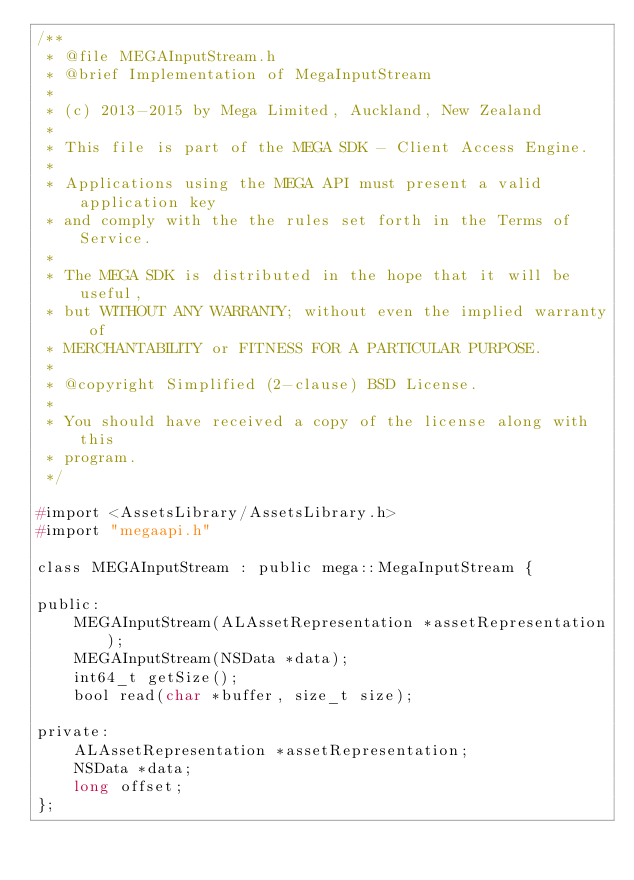Convert code to text. <code><loc_0><loc_0><loc_500><loc_500><_C_>/**
 * @file MEGAInputStream.h
 * @brief Implementation of MegaInputStream
 *
 * (c) 2013-2015 by Mega Limited, Auckland, New Zealand
 *
 * This file is part of the MEGA SDK - Client Access Engine.
 *
 * Applications using the MEGA API must present a valid application key
 * and comply with the the rules set forth in the Terms of Service.
 *
 * The MEGA SDK is distributed in the hope that it will be useful,
 * but WITHOUT ANY WARRANTY; without even the implied warranty of
 * MERCHANTABILITY or FITNESS FOR A PARTICULAR PURPOSE.
 *
 * @copyright Simplified (2-clause) BSD License.
 *
 * You should have received a copy of the license along with this
 * program.
 */

#import <AssetsLibrary/AssetsLibrary.h>
#import "megaapi.h"

class MEGAInputStream : public mega::MegaInputStream {

public:
    MEGAInputStream(ALAssetRepresentation *assetRepresentation);
    MEGAInputStream(NSData *data);
    int64_t getSize();
    bool read(char *buffer, size_t size);
    
private:
    ALAssetRepresentation *assetRepresentation;
    NSData *data;
    long offset;
};


</code> 